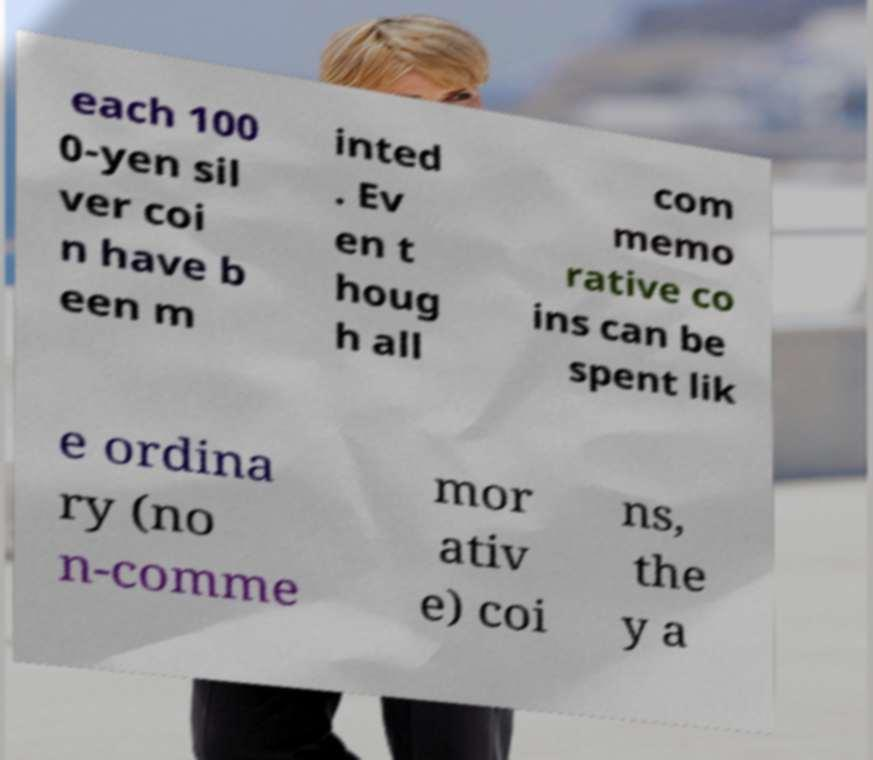Please identify and transcribe the text found in this image. each 100 0-yen sil ver coi n have b een m inted . Ev en t houg h all com memo rative co ins can be spent lik e ordina ry (no n-comme mor ativ e) coi ns, the y a 